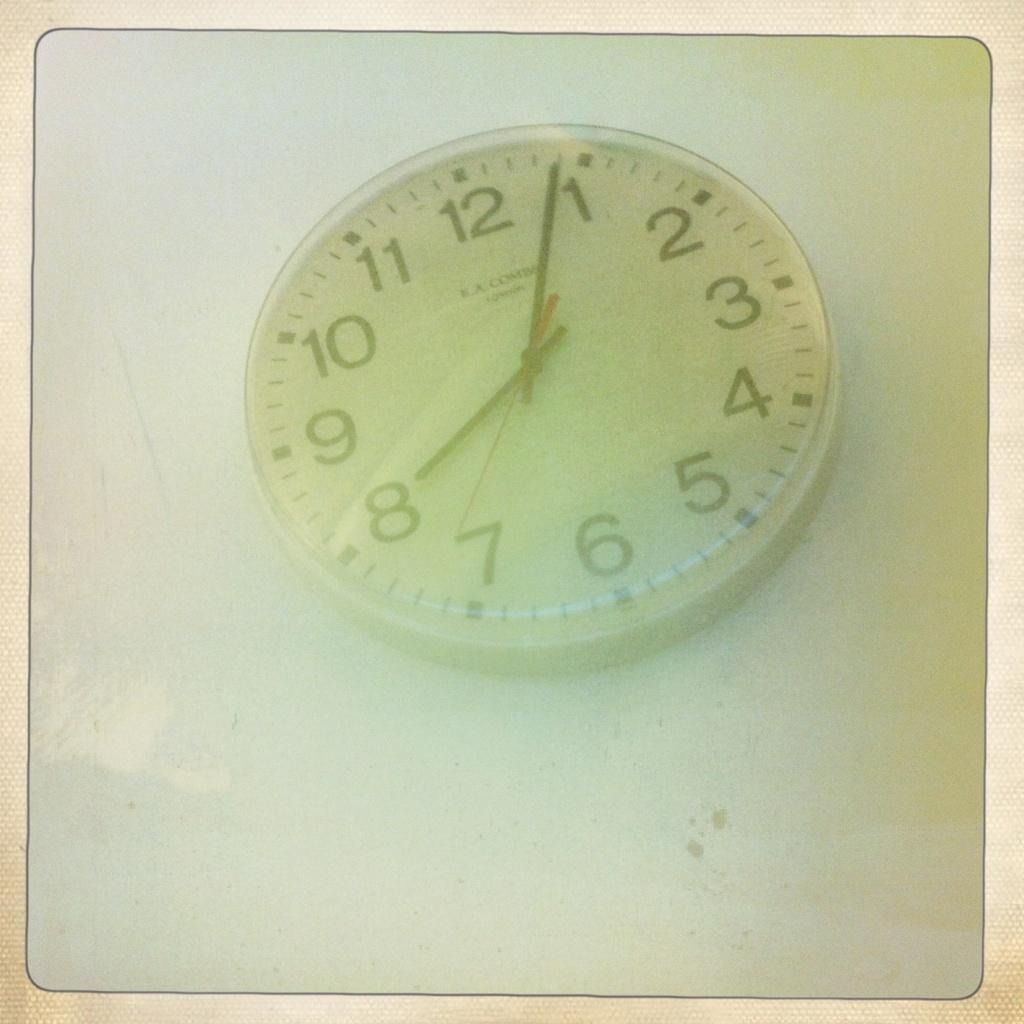<image>
Provide a brief description of the given image. Clock that says eight o four laying flat down 